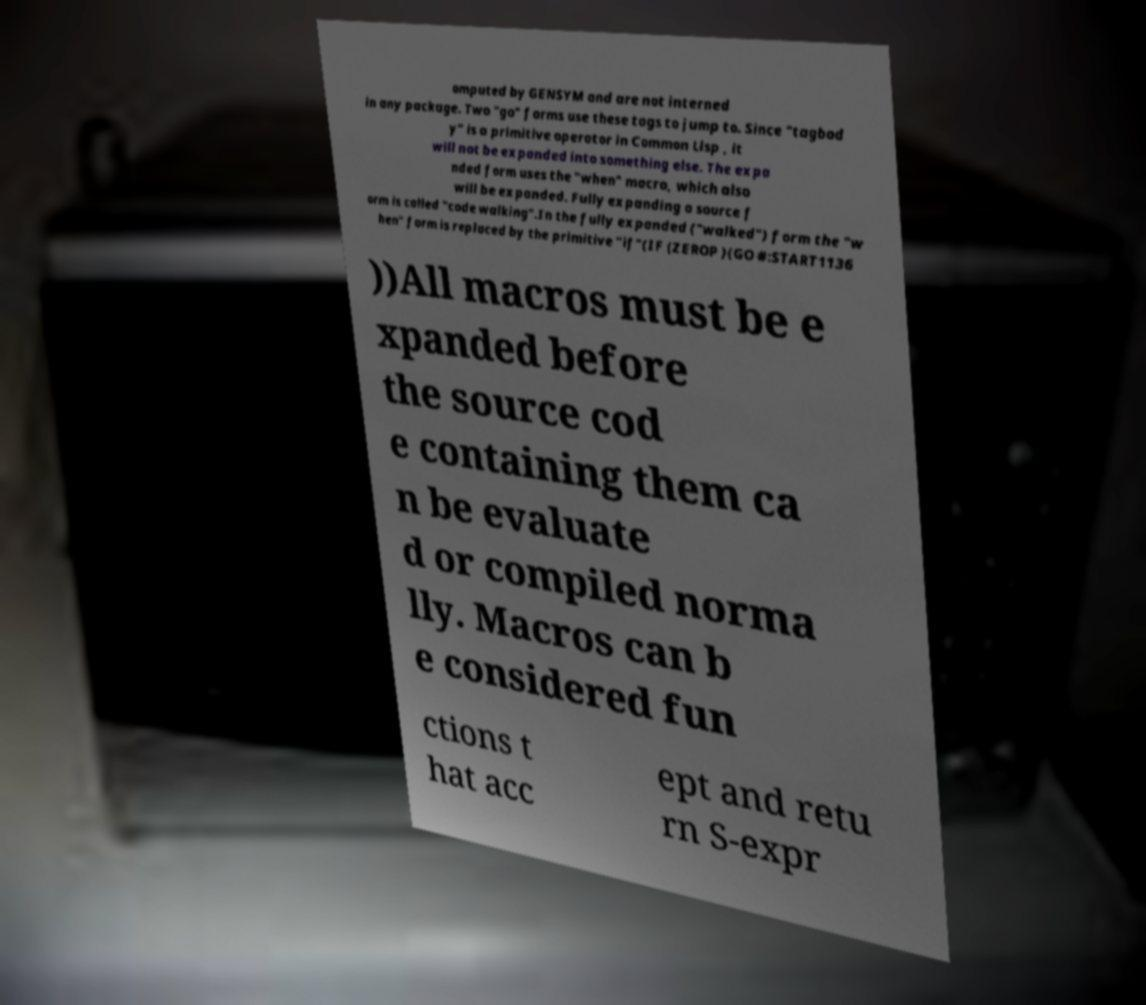Please identify and transcribe the text found in this image. omputed by GENSYM and are not interned in any package. Two "go" forms use these tags to jump to. Since "tagbod y" is a primitive operator in Common Lisp , it will not be expanded into something else. The expa nded form uses the "when" macro, which also will be expanded. Fully expanding a source f orm is called "code walking".In the fully expanded ("walked") form the "w hen" form is replaced by the primitive "if"(IF (ZEROP )(GO #:START1136 ))All macros must be e xpanded before the source cod e containing them ca n be evaluate d or compiled norma lly. Macros can b e considered fun ctions t hat acc ept and retu rn S-expr 